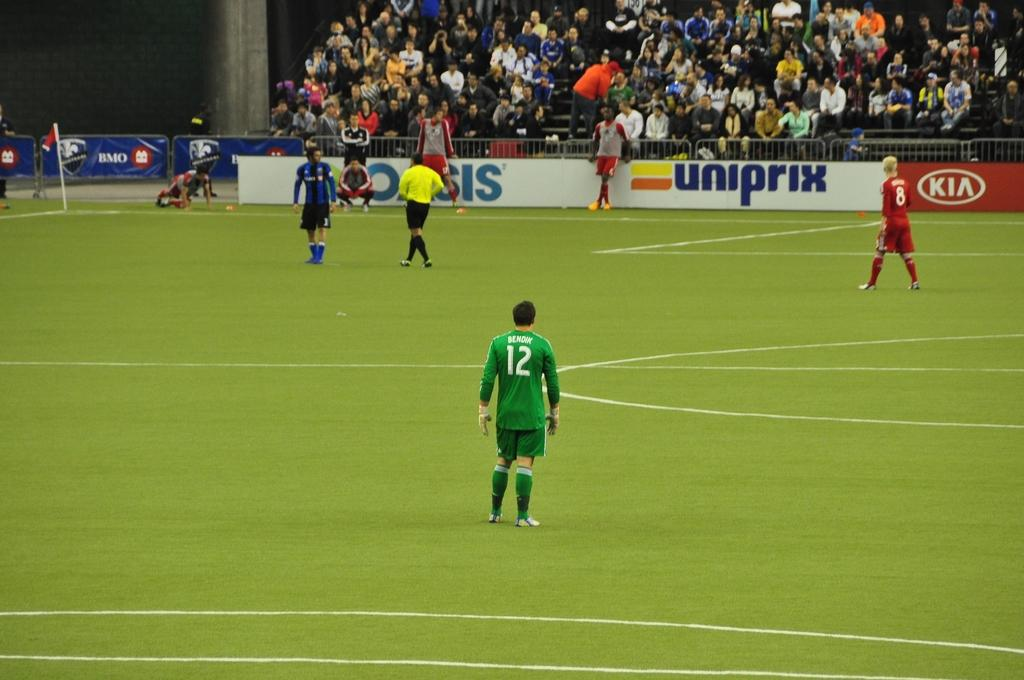What is the main subject in the foreground of the image? There is a man standing in the foreground of the image. What is the man standing on? The man is standing on the grass. What can be seen happening in the background of the image? There are people walking in the background of the image, and they are also walking on the grass. What is present in the background of the image besides the people walking? There is a banner and railing in the background of the image. What is the crowd in the background of the image doing? The crowd is sitting in the background of the image. How many clocks are visible in the image? There are no clocks visible in the image. What type of action is the example performing in the image? There is no example present in the image, and therefore no action can be attributed to it. 